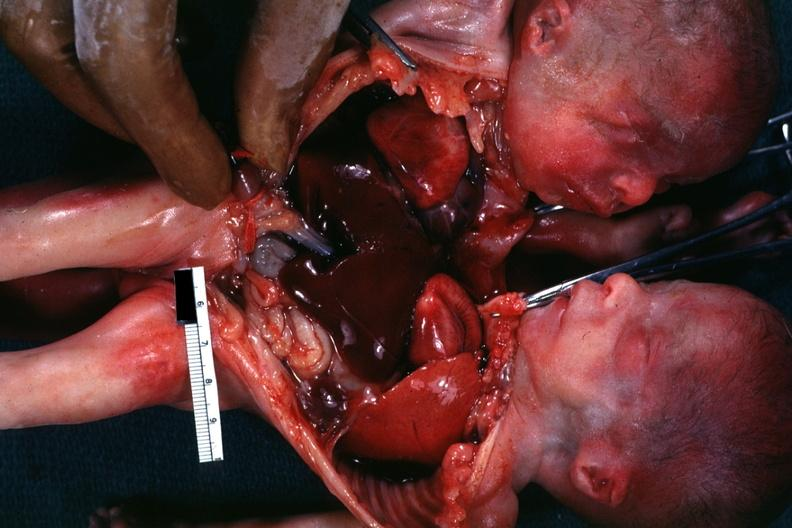s siamese twins present?
Answer the question using a single word or phrase. Yes 